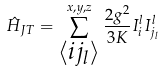<formula> <loc_0><loc_0><loc_500><loc_500>\hat { H } _ { J T } = \sum ^ { x , y , z } _ { \substack { \left < i j _ { l } \right > } } \frac { 2 g ^ { 2 } } { 3 K } I _ { i } ^ { l } I _ { j _ { l } } ^ { l }</formula> 